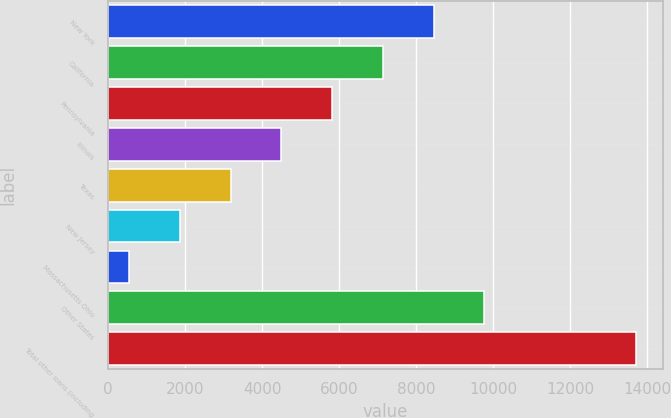Convert chart to OTSL. <chart><loc_0><loc_0><loc_500><loc_500><bar_chart><fcel>New York<fcel>California<fcel>Pennsylvania<fcel>Illinois<fcel>Texas<fcel>New Jersey<fcel>Massachusetts Ohio<fcel>Other States<fcel>Total other loans (including<nl><fcel>8451.4<fcel>7134.5<fcel>5817.6<fcel>4500.7<fcel>3183.8<fcel>1866.9<fcel>550<fcel>9768.3<fcel>13719<nl></chart> 